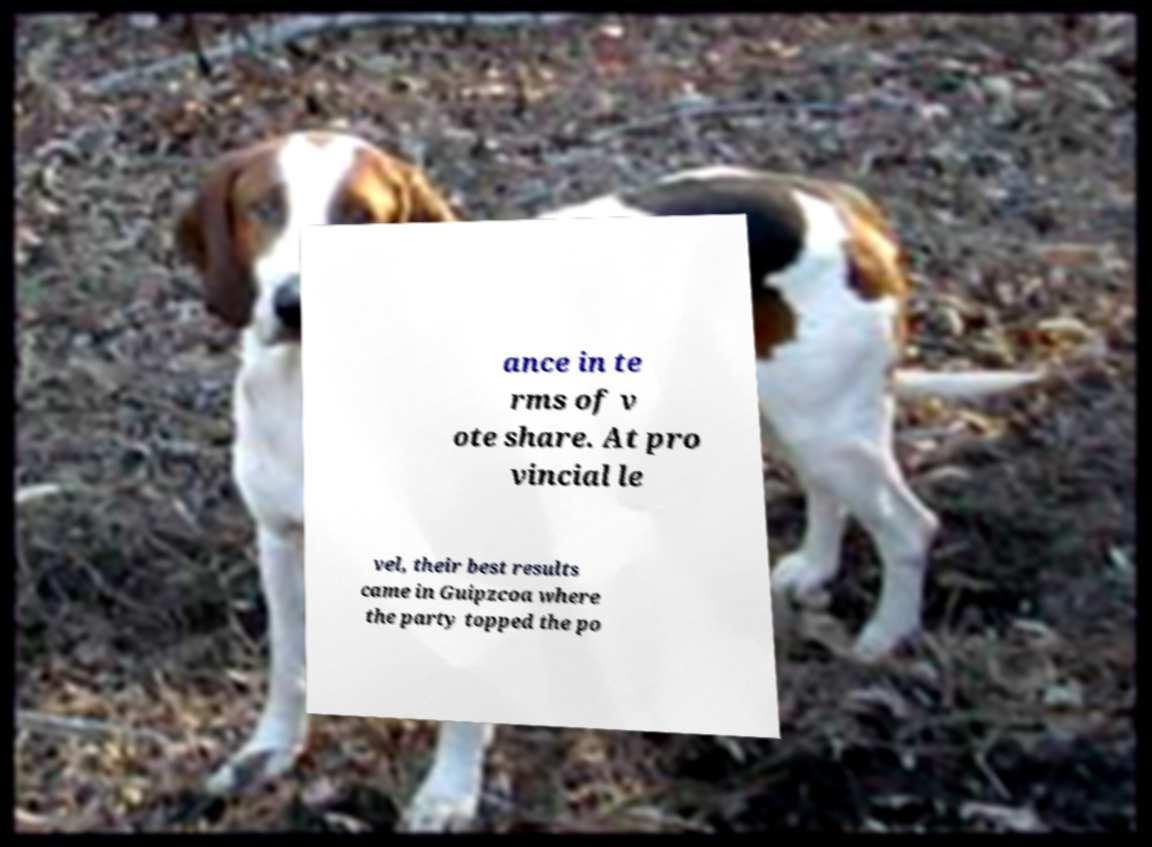Could you extract and type out the text from this image? ance in te rms of v ote share. At pro vincial le vel, their best results came in Guipzcoa where the party topped the po 